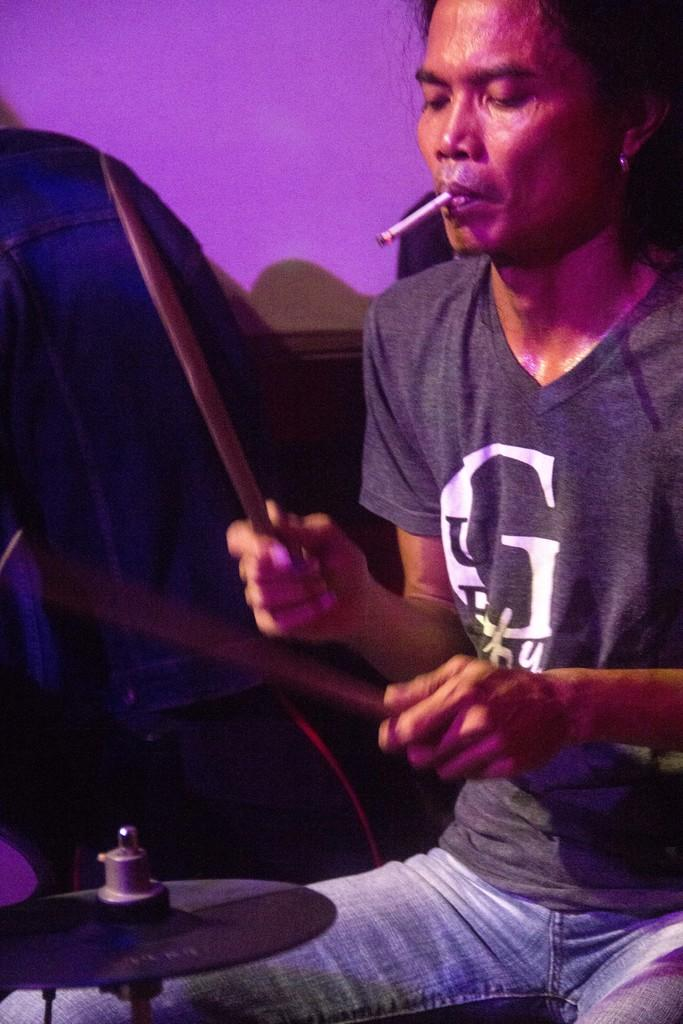Provide a one-sentence caption for the provided image. A man wearing a Guess shirt playing drums and smoking. 